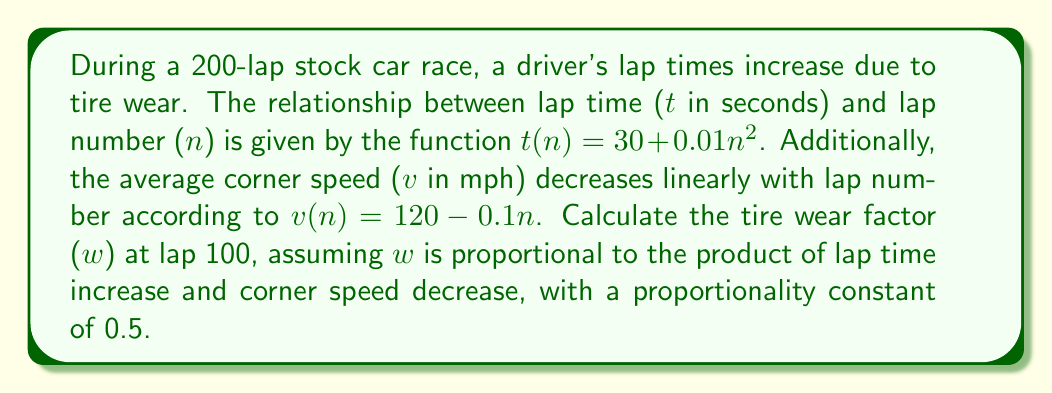Solve this math problem. To solve this inverse problem and calculate the tire wear factor, we'll follow these steps:

1. Calculate the lap time at lap 100:
   $t(100) = 30 + 0.01(100)^2 = 30 + 100 = 130$ seconds

2. Calculate the lap time increase from lap 1 to lap 100:
   $t(1) = 30 + 0.01(1)^2 = 30.01$ seconds
   Increase = $t(100) - t(1) = 130 - 30.01 = 99.99$ seconds

3. Calculate the average corner speed at lap 100:
   $v(100) = 120 - 0.1(100) = 110$ mph

4. Calculate the corner speed decrease from lap 1 to lap 100:
   $v(1) = 120 - 0.1(1) = 119.9$ mph
   Decrease = $v(1) - v(100) = 119.9 - 110 = 9.9$ mph

5. Calculate the tire wear factor using the given proportionality:
   $w = 0.5 \times (\text{lap time increase}) \times (\text{corner speed decrease})$
   $w = 0.5 \times 99.99 \times 9.9 = 494.9505$
Answer: 494.9505 